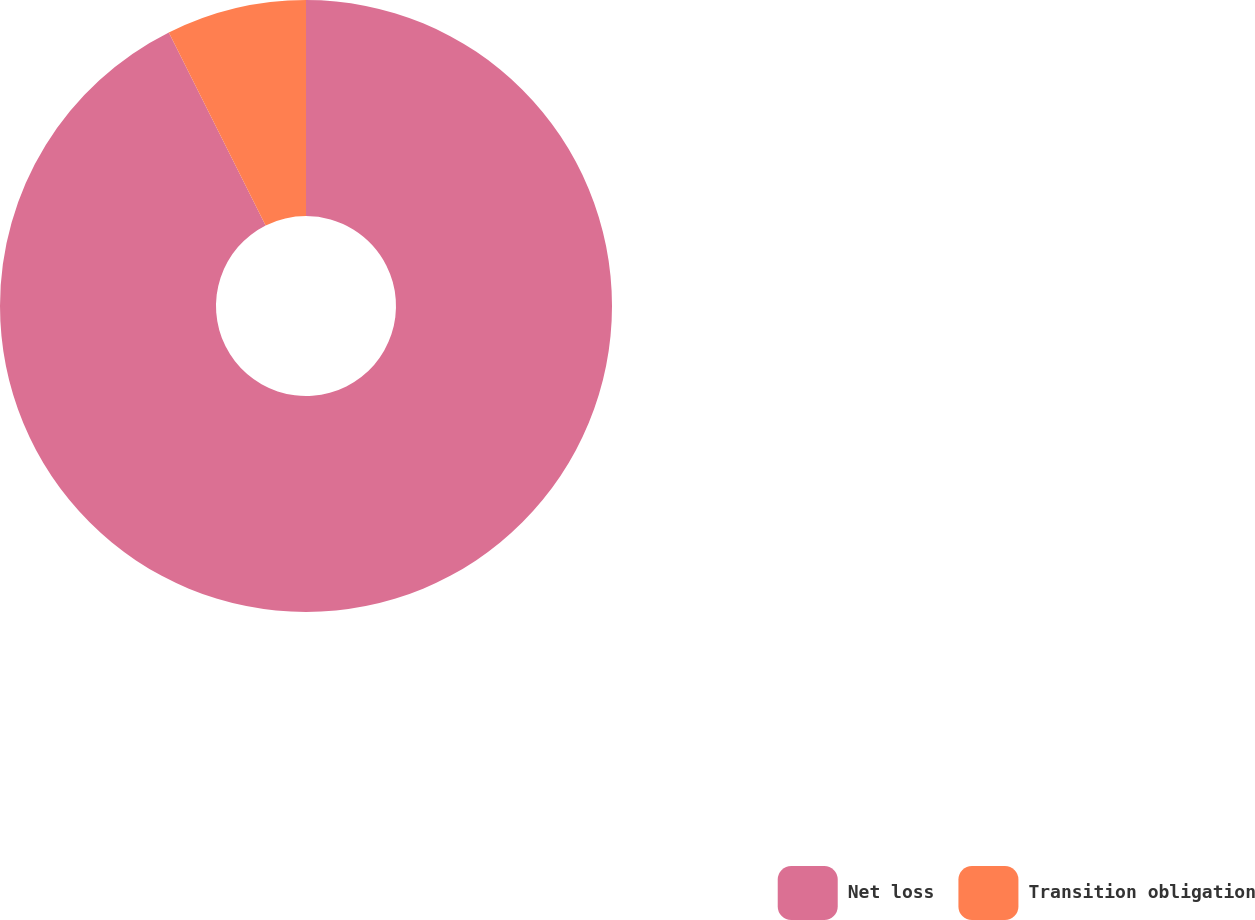Convert chart to OTSL. <chart><loc_0><loc_0><loc_500><loc_500><pie_chart><fcel>Net loss<fcel>Transition obligation<nl><fcel>92.6%<fcel>7.4%<nl></chart> 